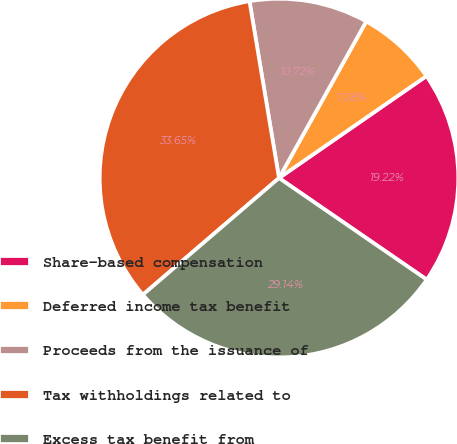<chart> <loc_0><loc_0><loc_500><loc_500><pie_chart><fcel>Share-based compensation<fcel>Deferred income tax benefit<fcel>Proceeds from the issuance of<fcel>Tax withholdings related to<fcel>Excess tax benefit from<nl><fcel>19.22%<fcel>7.28%<fcel>10.72%<fcel>33.65%<fcel>29.14%<nl></chart> 